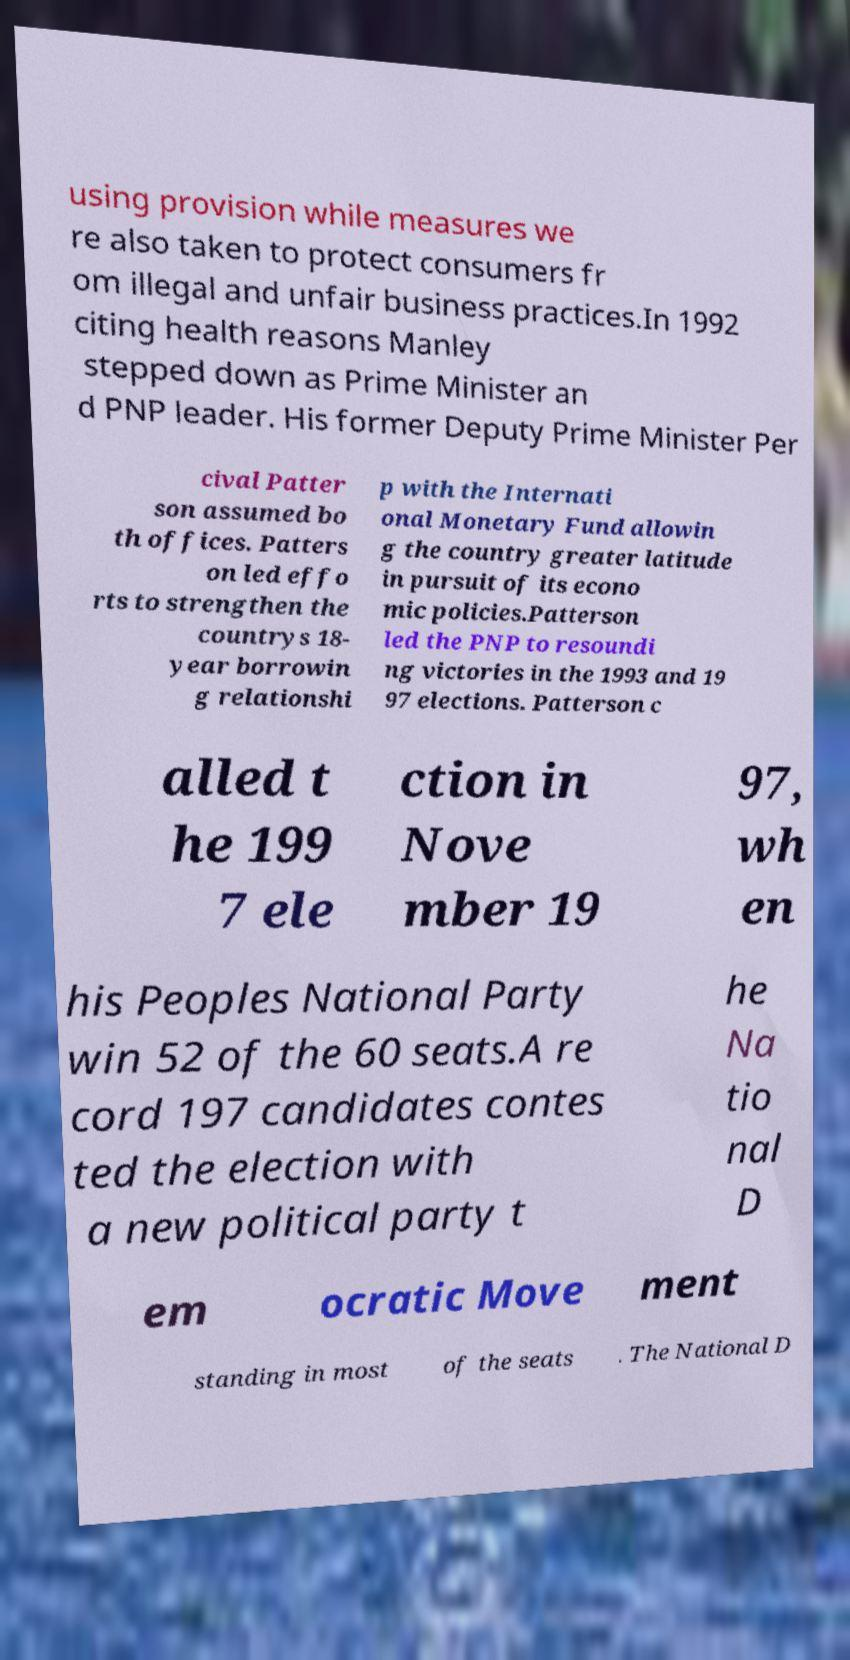What messages or text are displayed in this image? I need them in a readable, typed format. using provision while measures we re also taken to protect consumers fr om illegal and unfair business practices.In 1992 citing health reasons Manley stepped down as Prime Minister an d PNP leader. His former Deputy Prime Minister Per cival Patter son assumed bo th offices. Patters on led effo rts to strengthen the countrys 18- year borrowin g relationshi p with the Internati onal Monetary Fund allowin g the country greater latitude in pursuit of its econo mic policies.Patterson led the PNP to resoundi ng victories in the 1993 and 19 97 elections. Patterson c alled t he 199 7 ele ction in Nove mber 19 97, wh en his Peoples National Party win 52 of the 60 seats.A re cord 197 candidates contes ted the election with a new political party t he Na tio nal D em ocratic Move ment standing in most of the seats . The National D 